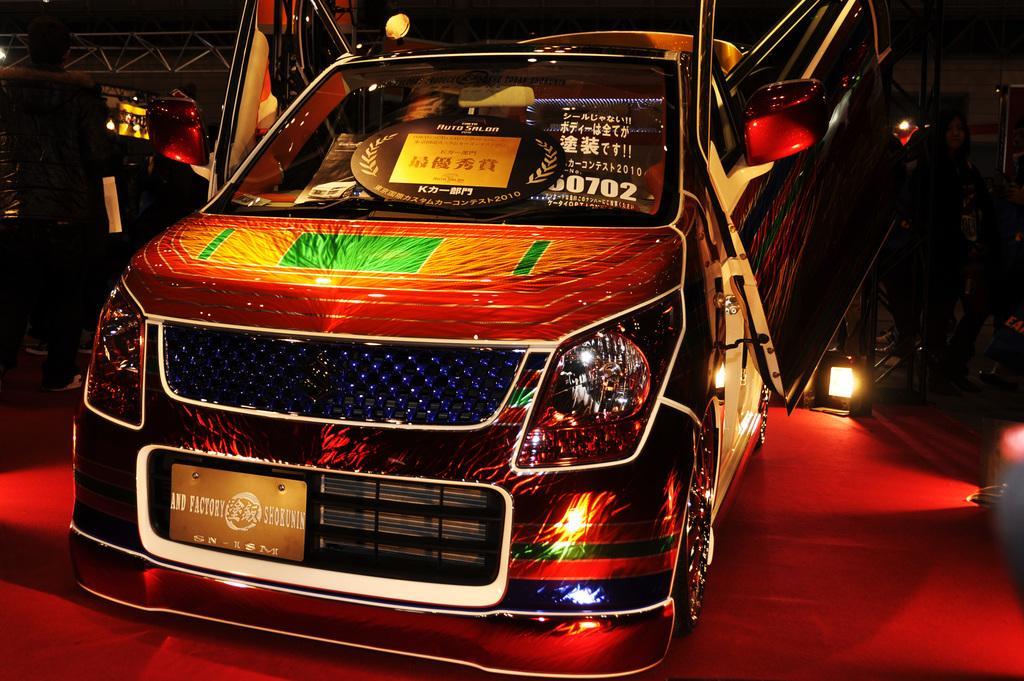In one or two sentences, can you explain what this image depicts? In this image we can see a vehicle. At the bottom there is a carpet. In the background we can see lights and there are rods. 